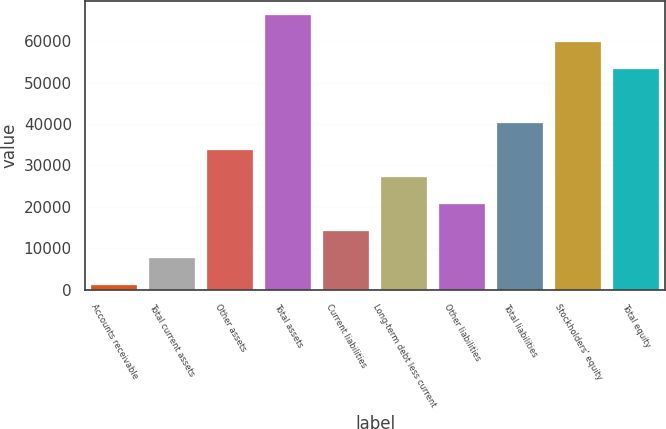<chart> <loc_0><loc_0><loc_500><loc_500><bar_chart><fcel>Accounts receivable<fcel>Total current assets<fcel>Other assets<fcel>Total assets<fcel>Current liabilities<fcel>Long-term debt less current<fcel>Other liabilities<fcel>Total liabilities<fcel>Stockholders' equity<fcel>Total equity<nl><fcel>1210<fcel>7715.2<fcel>33736<fcel>66352.4<fcel>14220.4<fcel>27230.8<fcel>20725.6<fcel>40241.2<fcel>59847.2<fcel>53342<nl></chart> 